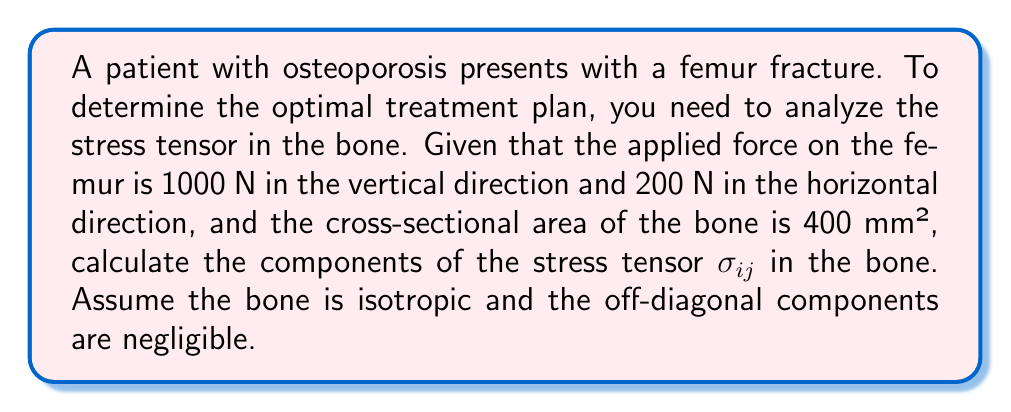Teach me how to tackle this problem. Let's approach this step-by-step:

1) The stress tensor $\sigma_{ij}$ for an isotropic material can be represented as:

   $$\sigma_{ij} = \begin{pmatrix}
   \sigma_{xx} & \sigma_{xy} & \sigma_{xz} \\
   \sigma_{yx} & \sigma_{yy} & \sigma_{yz} \\
   \sigma_{zx} & \sigma_{zy} & \sigma_{zz}
   \end{pmatrix}$$

2) Given that off-diagonal components are negligible, we only need to calculate $\sigma_{xx}$, $\sigma_{yy}$, and $\sigma_{zz}$.

3) Stress is defined as force per unit area. Let's assume the vertical force acts in the y-direction and the horizontal force in the x-direction.

4) For $\sigma_{yy}$:
   $$\sigma_{yy} = \frac{F_y}{A} = \frac{1000 \text{ N}}{400 \text{ mm}^2} = 2.5 \text{ MPa}$$

5) For $\sigma_{xx}$:
   $$\sigma_{xx} = \frac{F_x}{A} = \frac{200 \text{ N}}{400 \text{ mm}^2} = 0.5 \text{ MPa}$$

6) There's no force in the z-direction, so $\sigma_{zz} = 0$.

7) Therefore, the stress tensor becomes:

   $$\sigma_{ij} = \begin{pmatrix}
   0.5 & 0 & 0 \\
   0 & 2.5 & 0 \\
   0 & 0 & 0
   \end{pmatrix} \text{ MPa}$$
Answer: $\sigma_{ij} = \begin{pmatrix}
0.5 & 0 & 0 \\
0 & 2.5 & 0 \\
0 & 0 & 0
\end{pmatrix} \text{ MPa}$ 